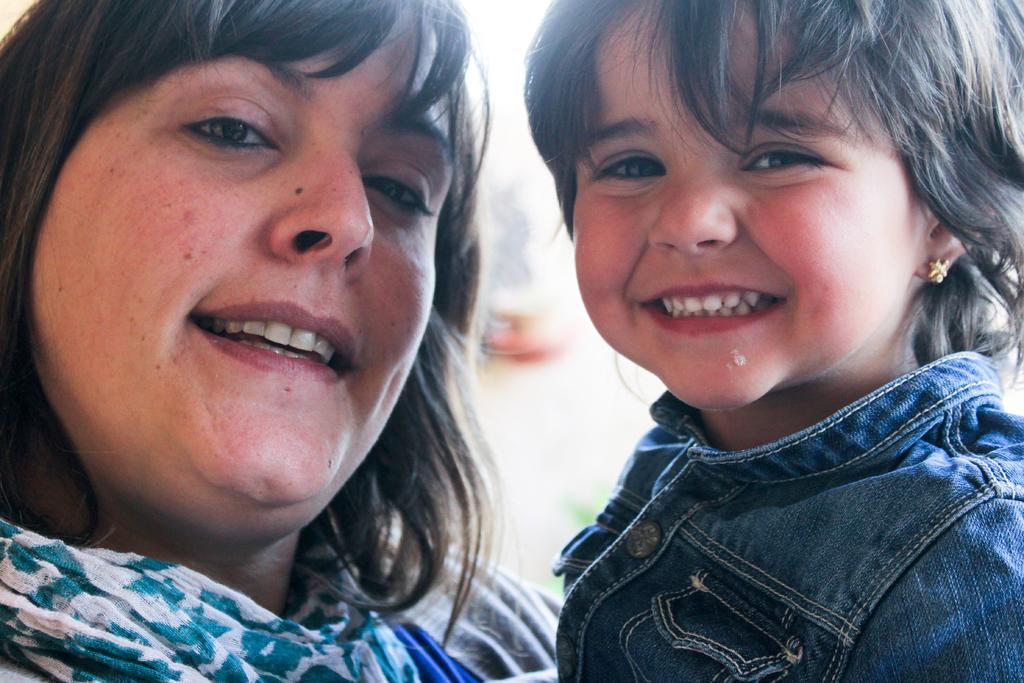Describe this image in one or two sentences. There is a woman and a girl. Both are smiling. In the background it is blurred. And the girl is wearing an earring. 